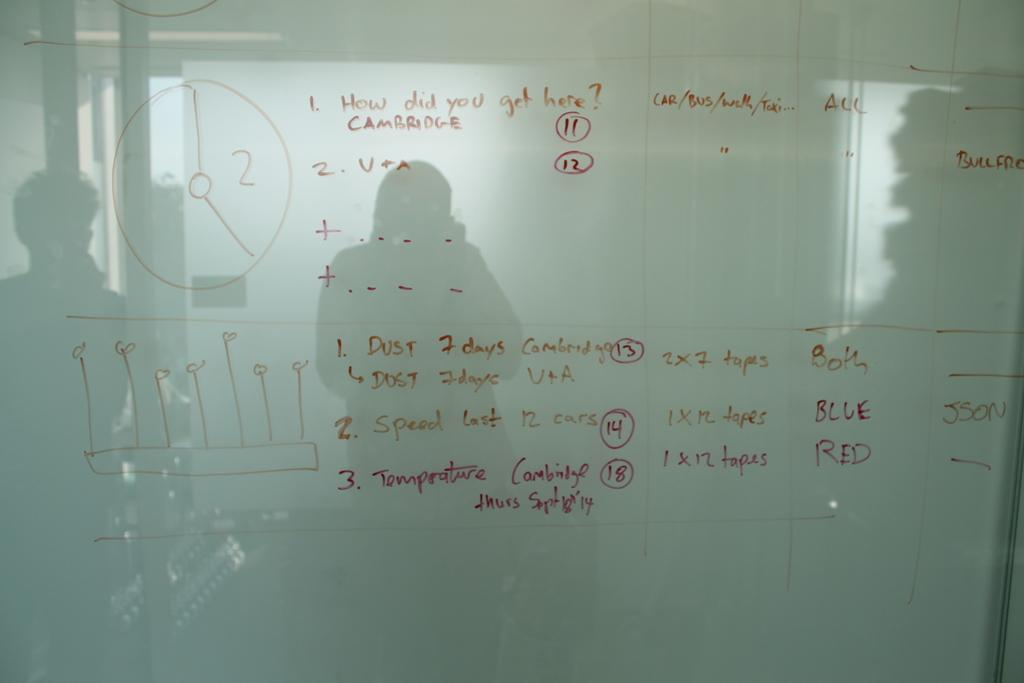<image>
Create a compact narrative representing the image presented. A white board discussing topics including "How did you get here?". 